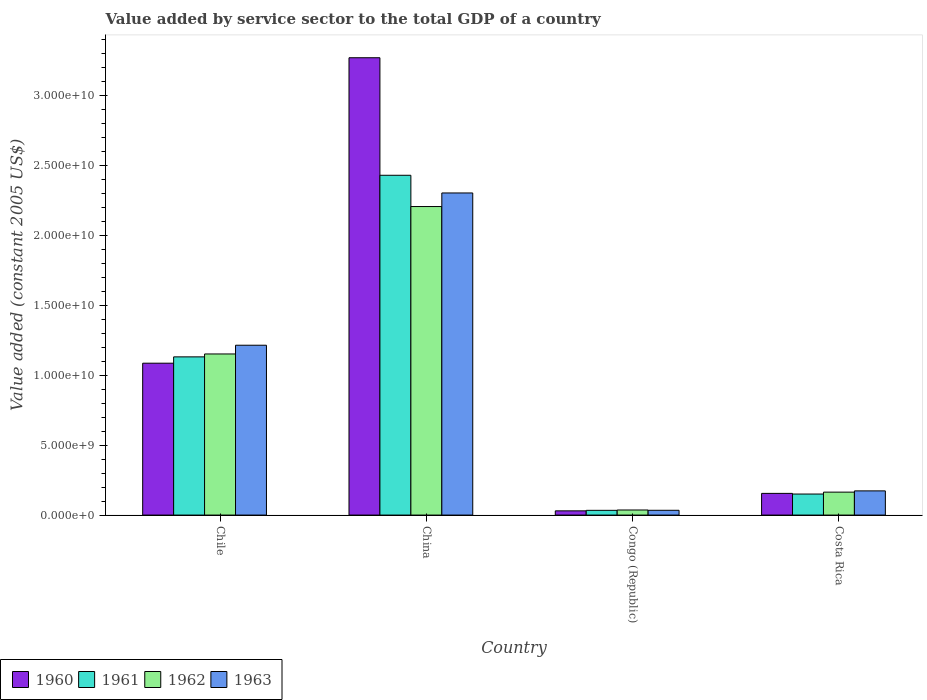How many bars are there on the 3rd tick from the left?
Provide a short and direct response. 4. How many bars are there on the 1st tick from the right?
Offer a very short reply. 4. What is the value added by service sector in 1963 in Costa Rica?
Provide a succinct answer. 1.73e+09. Across all countries, what is the maximum value added by service sector in 1963?
Provide a succinct answer. 2.30e+1. Across all countries, what is the minimum value added by service sector in 1961?
Your answer should be compact. 3.39e+08. In which country was the value added by service sector in 1961 minimum?
Ensure brevity in your answer.  Congo (Republic). What is the total value added by service sector in 1960 in the graph?
Offer a terse response. 4.54e+1. What is the difference between the value added by service sector in 1963 in China and that in Congo (Republic)?
Make the answer very short. 2.27e+1. What is the difference between the value added by service sector in 1961 in Chile and the value added by service sector in 1963 in Congo (Republic)?
Make the answer very short. 1.10e+1. What is the average value added by service sector in 1963 per country?
Keep it short and to the point. 9.32e+09. What is the difference between the value added by service sector of/in 1962 and value added by service sector of/in 1963 in Chile?
Your answer should be very brief. -6.25e+08. What is the ratio of the value added by service sector in 1960 in Congo (Republic) to that in Costa Rica?
Your answer should be compact. 0.19. Is the difference between the value added by service sector in 1962 in China and Congo (Republic) greater than the difference between the value added by service sector in 1963 in China and Congo (Republic)?
Ensure brevity in your answer.  No. What is the difference between the highest and the second highest value added by service sector in 1963?
Keep it short and to the point. -2.13e+1. What is the difference between the highest and the lowest value added by service sector in 1960?
Offer a very short reply. 3.24e+1. Is it the case that in every country, the sum of the value added by service sector in 1960 and value added by service sector in 1963 is greater than the value added by service sector in 1961?
Your response must be concise. Yes. How many bars are there?
Offer a very short reply. 16. Are the values on the major ticks of Y-axis written in scientific E-notation?
Make the answer very short. Yes. Does the graph contain any zero values?
Give a very brief answer. No. Does the graph contain grids?
Give a very brief answer. No. Where does the legend appear in the graph?
Provide a succinct answer. Bottom left. How many legend labels are there?
Offer a very short reply. 4. How are the legend labels stacked?
Keep it short and to the point. Horizontal. What is the title of the graph?
Your answer should be compact. Value added by service sector to the total GDP of a country. Does "2013" appear as one of the legend labels in the graph?
Offer a terse response. No. What is the label or title of the X-axis?
Keep it short and to the point. Country. What is the label or title of the Y-axis?
Ensure brevity in your answer.  Value added (constant 2005 US$). What is the Value added (constant 2005 US$) of 1960 in Chile?
Your response must be concise. 1.09e+1. What is the Value added (constant 2005 US$) in 1961 in Chile?
Your answer should be compact. 1.13e+1. What is the Value added (constant 2005 US$) of 1962 in Chile?
Provide a short and direct response. 1.15e+1. What is the Value added (constant 2005 US$) of 1963 in Chile?
Keep it short and to the point. 1.22e+1. What is the Value added (constant 2005 US$) of 1960 in China?
Provide a short and direct response. 3.27e+1. What is the Value added (constant 2005 US$) in 1961 in China?
Offer a very short reply. 2.43e+1. What is the Value added (constant 2005 US$) of 1962 in China?
Give a very brief answer. 2.21e+1. What is the Value added (constant 2005 US$) of 1963 in China?
Make the answer very short. 2.30e+1. What is the Value added (constant 2005 US$) in 1960 in Congo (Republic)?
Make the answer very short. 3.02e+08. What is the Value added (constant 2005 US$) in 1961 in Congo (Republic)?
Provide a succinct answer. 3.39e+08. What is the Value added (constant 2005 US$) in 1962 in Congo (Republic)?
Your response must be concise. 3.64e+08. What is the Value added (constant 2005 US$) in 1963 in Congo (Republic)?
Your response must be concise. 3.42e+08. What is the Value added (constant 2005 US$) in 1960 in Costa Rica?
Your answer should be very brief. 1.55e+09. What is the Value added (constant 2005 US$) of 1961 in Costa Rica?
Offer a very short reply. 1.51e+09. What is the Value added (constant 2005 US$) of 1962 in Costa Rica?
Provide a succinct answer. 1.64e+09. What is the Value added (constant 2005 US$) in 1963 in Costa Rica?
Keep it short and to the point. 1.73e+09. Across all countries, what is the maximum Value added (constant 2005 US$) of 1960?
Provide a succinct answer. 3.27e+1. Across all countries, what is the maximum Value added (constant 2005 US$) in 1961?
Your answer should be very brief. 2.43e+1. Across all countries, what is the maximum Value added (constant 2005 US$) in 1962?
Your answer should be very brief. 2.21e+1. Across all countries, what is the maximum Value added (constant 2005 US$) of 1963?
Your response must be concise. 2.30e+1. Across all countries, what is the minimum Value added (constant 2005 US$) of 1960?
Provide a succinct answer. 3.02e+08. Across all countries, what is the minimum Value added (constant 2005 US$) of 1961?
Your answer should be very brief. 3.39e+08. Across all countries, what is the minimum Value added (constant 2005 US$) of 1962?
Your response must be concise. 3.64e+08. Across all countries, what is the minimum Value added (constant 2005 US$) in 1963?
Provide a succinct answer. 3.42e+08. What is the total Value added (constant 2005 US$) of 1960 in the graph?
Keep it short and to the point. 4.54e+1. What is the total Value added (constant 2005 US$) in 1961 in the graph?
Your answer should be very brief. 3.75e+1. What is the total Value added (constant 2005 US$) in 1962 in the graph?
Provide a succinct answer. 3.56e+1. What is the total Value added (constant 2005 US$) in 1963 in the graph?
Your answer should be very brief. 3.73e+1. What is the difference between the Value added (constant 2005 US$) of 1960 in Chile and that in China?
Ensure brevity in your answer.  -2.19e+1. What is the difference between the Value added (constant 2005 US$) of 1961 in Chile and that in China?
Provide a short and direct response. -1.30e+1. What is the difference between the Value added (constant 2005 US$) of 1962 in Chile and that in China?
Provide a short and direct response. -1.05e+1. What is the difference between the Value added (constant 2005 US$) of 1963 in Chile and that in China?
Your response must be concise. -1.09e+1. What is the difference between the Value added (constant 2005 US$) in 1960 in Chile and that in Congo (Republic)?
Provide a succinct answer. 1.06e+1. What is the difference between the Value added (constant 2005 US$) of 1961 in Chile and that in Congo (Republic)?
Your answer should be compact. 1.10e+1. What is the difference between the Value added (constant 2005 US$) in 1962 in Chile and that in Congo (Republic)?
Provide a short and direct response. 1.12e+1. What is the difference between the Value added (constant 2005 US$) in 1963 in Chile and that in Congo (Republic)?
Offer a very short reply. 1.18e+1. What is the difference between the Value added (constant 2005 US$) of 1960 in Chile and that in Costa Rica?
Your response must be concise. 9.31e+09. What is the difference between the Value added (constant 2005 US$) of 1961 in Chile and that in Costa Rica?
Your response must be concise. 9.81e+09. What is the difference between the Value added (constant 2005 US$) of 1962 in Chile and that in Costa Rica?
Your response must be concise. 9.89e+09. What is the difference between the Value added (constant 2005 US$) of 1963 in Chile and that in Costa Rica?
Ensure brevity in your answer.  1.04e+1. What is the difference between the Value added (constant 2005 US$) of 1960 in China and that in Congo (Republic)?
Provide a short and direct response. 3.24e+1. What is the difference between the Value added (constant 2005 US$) in 1961 in China and that in Congo (Republic)?
Make the answer very short. 2.40e+1. What is the difference between the Value added (constant 2005 US$) in 1962 in China and that in Congo (Republic)?
Keep it short and to the point. 2.17e+1. What is the difference between the Value added (constant 2005 US$) of 1963 in China and that in Congo (Republic)?
Your answer should be very brief. 2.27e+1. What is the difference between the Value added (constant 2005 US$) in 1960 in China and that in Costa Rica?
Make the answer very short. 3.12e+1. What is the difference between the Value added (constant 2005 US$) in 1961 in China and that in Costa Rica?
Your answer should be very brief. 2.28e+1. What is the difference between the Value added (constant 2005 US$) of 1962 in China and that in Costa Rica?
Offer a very short reply. 2.04e+1. What is the difference between the Value added (constant 2005 US$) in 1963 in China and that in Costa Rica?
Offer a terse response. 2.13e+1. What is the difference between the Value added (constant 2005 US$) of 1960 in Congo (Republic) and that in Costa Rica?
Offer a terse response. -1.25e+09. What is the difference between the Value added (constant 2005 US$) in 1961 in Congo (Republic) and that in Costa Rica?
Make the answer very short. -1.17e+09. What is the difference between the Value added (constant 2005 US$) of 1962 in Congo (Republic) and that in Costa Rica?
Provide a succinct answer. -1.28e+09. What is the difference between the Value added (constant 2005 US$) in 1963 in Congo (Republic) and that in Costa Rica?
Offer a terse response. -1.39e+09. What is the difference between the Value added (constant 2005 US$) in 1960 in Chile and the Value added (constant 2005 US$) in 1961 in China?
Your response must be concise. -1.34e+1. What is the difference between the Value added (constant 2005 US$) of 1960 in Chile and the Value added (constant 2005 US$) of 1962 in China?
Keep it short and to the point. -1.12e+1. What is the difference between the Value added (constant 2005 US$) of 1960 in Chile and the Value added (constant 2005 US$) of 1963 in China?
Provide a succinct answer. -1.22e+1. What is the difference between the Value added (constant 2005 US$) in 1961 in Chile and the Value added (constant 2005 US$) in 1962 in China?
Offer a very short reply. -1.08e+1. What is the difference between the Value added (constant 2005 US$) of 1961 in Chile and the Value added (constant 2005 US$) of 1963 in China?
Your response must be concise. -1.17e+1. What is the difference between the Value added (constant 2005 US$) in 1962 in Chile and the Value added (constant 2005 US$) in 1963 in China?
Give a very brief answer. -1.15e+1. What is the difference between the Value added (constant 2005 US$) of 1960 in Chile and the Value added (constant 2005 US$) of 1961 in Congo (Republic)?
Provide a succinct answer. 1.05e+1. What is the difference between the Value added (constant 2005 US$) in 1960 in Chile and the Value added (constant 2005 US$) in 1962 in Congo (Republic)?
Keep it short and to the point. 1.05e+1. What is the difference between the Value added (constant 2005 US$) of 1960 in Chile and the Value added (constant 2005 US$) of 1963 in Congo (Republic)?
Offer a terse response. 1.05e+1. What is the difference between the Value added (constant 2005 US$) of 1961 in Chile and the Value added (constant 2005 US$) of 1962 in Congo (Republic)?
Give a very brief answer. 1.10e+1. What is the difference between the Value added (constant 2005 US$) of 1961 in Chile and the Value added (constant 2005 US$) of 1963 in Congo (Republic)?
Offer a terse response. 1.10e+1. What is the difference between the Value added (constant 2005 US$) of 1962 in Chile and the Value added (constant 2005 US$) of 1963 in Congo (Republic)?
Your answer should be very brief. 1.12e+1. What is the difference between the Value added (constant 2005 US$) in 1960 in Chile and the Value added (constant 2005 US$) in 1961 in Costa Rica?
Your response must be concise. 9.36e+09. What is the difference between the Value added (constant 2005 US$) in 1960 in Chile and the Value added (constant 2005 US$) in 1962 in Costa Rica?
Offer a very short reply. 9.23e+09. What is the difference between the Value added (constant 2005 US$) of 1960 in Chile and the Value added (constant 2005 US$) of 1963 in Costa Rica?
Ensure brevity in your answer.  9.14e+09. What is the difference between the Value added (constant 2005 US$) of 1961 in Chile and the Value added (constant 2005 US$) of 1962 in Costa Rica?
Your answer should be compact. 9.68e+09. What is the difference between the Value added (constant 2005 US$) of 1961 in Chile and the Value added (constant 2005 US$) of 1963 in Costa Rica?
Your answer should be compact. 9.59e+09. What is the difference between the Value added (constant 2005 US$) of 1962 in Chile and the Value added (constant 2005 US$) of 1963 in Costa Rica?
Offer a terse response. 9.80e+09. What is the difference between the Value added (constant 2005 US$) in 1960 in China and the Value added (constant 2005 US$) in 1961 in Congo (Republic)?
Give a very brief answer. 3.24e+1. What is the difference between the Value added (constant 2005 US$) in 1960 in China and the Value added (constant 2005 US$) in 1962 in Congo (Republic)?
Offer a terse response. 3.24e+1. What is the difference between the Value added (constant 2005 US$) in 1960 in China and the Value added (constant 2005 US$) in 1963 in Congo (Republic)?
Provide a short and direct response. 3.24e+1. What is the difference between the Value added (constant 2005 US$) of 1961 in China and the Value added (constant 2005 US$) of 1962 in Congo (Republic)?
Your answer should be compact. 2.39e+1. What is the difference between the Value added (constant 2005 US$) in 1961 in China and the Value added (constant 2005 US$) in 1963 in Congo (Republic)?
Make the answer very short. 2.40e+1. What is the difference between the Value added (constant 2005 US$) of 1962 in China and the Value added (constant 2005 US$) of 1963 in Congo (Republic)?
Ensure brevity in your answer.  2.17e+1. What is the difference between the Value added (constant 2005 US$) of 1960 in China and the Value added (constant 2005 US$) of 1961 in Costa Rica?
Your answer should be very brief. 3.12e+1. What is the difference between the Value added (constant 2005 US$) in 1960 in China and the Value added (constant 2005 US$) in 1962 in Costa Rica?
Ensure brevity in your answer.  3.11e+1. What is the difference between the Value added (constant 2005 US$) in 1960 in China and the Value added (constant 2005 US$) in 1963 in Costa Rica?
Provide a succinct answer. 3.10e+1. What is the difference between the Value added (constant 2005 US$) in 1961 in China and the Value added (constant 2005 US$) in 1962 in Costa Rica?
Ensure brevity in your answer.  2.27e+1. What is the difference between the Value added (constant 2005 US$) in 1961 in China and the Value added (constant 2005 US$) in 1963 in Costa Rica?
Offer a very short reply. 2.26e+1. What is the difference between the Value added (constant 2005 US$) in 1962 in China and the Value added (constant 2005 US$) in 1963 in Costa Rica?
Ensure brevity in your answer.  2.03e+1. What is the difference between the Value added (constant 2005 US$) in 1960 in Congo (Republic) and the Value added (constant 2005 US$) in 1961 in Costa Rica?
Your answer should be compact. -1.20e+09. What is the difference between the Value added (constant 2005 US$) of 1960 in Congo (Republic) and the Value added (constant 2005 US$) of 1962 in Costa Rica?
Provide a short and direct response. -1.34e+09. What is the difference between the Value added (constant 2005 US$) in 1960 in Congo (Republic) and the Value added (constant 2005 US$) in 1963 in Costa Rica?
Your response must be concise. -1.43e+09. What is the difference between the Value added (constant 2005 US$) of 1961 in Congo (Republic) and the Value added (constant 2005 US$) of 1962 in Costa Rica?
Keep it short and to the point. -1.30e+09. What is the difference between the Value added (constant 2005 US$) in 1961 in Congo (Republic) and the Value added (constant 2005 US$) in 1963 in Costa Rica?
Your answer should be compact. -1.39e+09. What is the difference between the Value added (constant 2005 US$) of 1962 in Congo (Republic) and the Value added (constant 2005 US$) of 1963 in Costa Rica?
Your answer should be very brief. -1.37e+09. What is the average Value added (constant 2005 US$) in 1960 per country?
Make the answer very short. 1.14e+1. What is the average Value added (constant 2005 US$) in 1961 per country?
Ensure brevity in your answer.  9.37e+09. What is the average Value added (constant 2005 US$) of 1962 per country?
Ensure brevity in your answer.  8.90e+09. What is the average Value added (constant 2005 US$) of 1963 per country?
Provide a short and direct response. 9.32e+09. What is the difference between the Value added (constant 2005 US$) in 1960 and Value added (constant 2005 US$) in 1961 in Chile?
Offer a very short reply. -4.53e+08. What is the difference between the Value added (constant 2005 US$) in 1960 and Value added (constant 2005 US$) in 1962 in Chile?
Make the answer very short. -6.60e+08. What is the difference between the Value added (constant 2005 US$) in 1960 and Value added (constant 2005 US$) in 1963 in Chile?
Give a very brief answer. -1.29e+09. What is the difference between the Value added (constant 2005 US$) in 1961 and Value added (constant 2005 US$) in 1962 in Chile?
Offer a very short reply. -2.07e+08. What is the difference between the Value added (constant 2005 US$) in 1961 and Value added (constant 2005 US$) in 1963 in Chile?
Your answer should be very brief. -8.32e+08. What is the difference between the Value added (constant 2005 US$) of 1962 and Value added (constant 2005 US$) of 1963 in Chile?
Provide a short and direct response. -6.25e+08. What is the difference between the Value added (constant 2005 US$) of 1960 and Value added (constant 2005 US$) of 1961 in China?
Make the answer very short. 8.41e+09. What is the difference between the Value added (constant 2005 US$) of 1960 and Value added (constant 2005 US$) of 1962 in China?
Make the answer very short. 1.06e+1. What is the difference between the Value added (constant 2005 US$) in 1960 and Value added (constant 2005 US$) in 1963 in China?
Offer a very short reply. 9.68e+09. What is the difference between the Value added (constant 2005 US$) of 1961 and Value added (constant 2005 US$) of 1962 in China?
Offer a terse response. 2.24e+09. What is the difference between the Value added (constant 2005 US$) in 1961 and Value added (constant 2005 US$) in 1963 in China?
Offer a terse response. 1.27e+09. What is the difference between the Value added (constant 2005 US$) in 1962 and Value added (constant 2005 US$) in 1963 in China?
Provide a short and direct response. -9.71e+08. What is the difference between the Value added (constant 2005 US$) of 1960 and Value added (constant 2005 US$) of 1961 in Congo (Republic)?
Your answer should be compact. -3.74e+07. What is the difference between the Value added (constant 2005 US$) of 1960 and Value added (constant 2005 US$) of 1962 in Congo (Republic)?
Provide a short and direct response. -6.23e+07. What is the difference between the Value added (constant 2005 US$) in 1960 and Value added (constant 2005 US$) in 1963 in Congo (Republic)?
Offer a terse response. -4.05e+07. What is the difference between the Value added (constant 2005 US$) in 1961 and Value added (constant 2005 US$) in 1962 in Congo (Republic)?
Ensure brevity in your answer.  -2.49e+07. What is the difference between the Value added (constant 2005 US$) of 1961 and Value added (constant 2005 US$) of 1963 in Congo (Republic)?
Offer a very short reply. -3.09e+06. What is the difference between the Value added (constant 2005 US$) of 1962 and Value added (constant 2005 US$) of 1963 in Congo (Republic)?
Ensure brevity in your answer.  2.18e+07. What is the difference between the Value added (constant 2005 US$) of 1960 and Value added (constant 2005 US$) of 1961 in Costa Rica?
Keep it short and to the point. 4.72e+07. What is the difference between the Value added (constant 2005 US$) in 1960 and Value added (constant 2005 US$) in 1962 in Costa Rica?
Provide a succinct answer. -8.87e+07. What is the difference between the Value added (constant 2005 US$) in 1960 and Value added (constant 2005 US$) in 1963 in Costa Rica?
Your answer should be compact. -1.78e+08. What is the difference between the Value added (constant 2005 US$) of 1961 and Value added (constant 2005 US$) of 1962 in Costa Rica?
Your response must be concise. -1.36e+08. What is the difference between the Value added (constant 2005 US$) in 1961 and Value added (constant 2005 US$) in 1963 in Costa Rica?
Your answer should be compact. -2.25e+08. What is the difference between the Value added (constant 2005 US$) of 1962 and Value added (constant 2005 US$) of 1963 in Costa Rica?
Your response must be concise. -8.94e+07. What is the ratio of the Value added (constant 2005 US$) in 1960 in Chile to that in China?
Offer a very short reply. 0.33. What is the ratio of the Value added (constant 2005 US$) of 1961 in Chile to that in China?
Offer a very short reply. 0.47. What is the ratio of the Value added (constant 2005 US$) of 1962 in Chile to that in China?
Your response must be concise. 0.52. What is the ratio of the Value added (constant 2005 US$) of 1963 in Chile to that in China?
Make the answer very short. 0.53. What is the ratio of the Value added (constant 2005 US$) in 1960 in Chile to that in Congo (Republic)?
Offer a very short reply. 36.04. What is the ratio of the Value added (constant 2005 US$) in 1961 in Chile to that in Congo (Republic)?
Provide a short and direct response. 33.4. What is the ratio of the Value added (constant 2005 US$) of 1962 in Chile to that in Congo (Republic)?
Ensure brevity in your answer.  31.68. What is the ratio of the Value added (constant 2005 US$) of 1963 in Chile to that in Congo (Republic)?
Provide a succinct answer. 35.53. What is the ratio of the Value added (constant 2005 US$) of 1960 in Chile to that in Costa Rica?
Keep it short and to the point. 7. What is the ratio of the Value added (constant 2005 US$) of 1961 in Chile to that in Costa Rica?
Make the answer very short. 7.52. What is the ratio of the Value added (constant 2005 US$) of 1962 in Chile to that in Costa Rica?
Provide a short and direct response. 7.02. What is the ratio of the Value added (constant 2005 US$) in 1963 in Chile to that in Costa Rica?
Provide a succinct answer. 7.02. What is the ratio of the Value added (constant 2005 US$) in 1960 in China to that in Congo (Republic)?
Provide a short and direct response. 108.51. What is the ratio of the Value added (constant 2005 US$) of 1961 in China to that in Congo (Republic)?
Offer a terse response. 71.73. What is the ratio of the Value added (constant 2005 US$) of 1962 in China to that in Congo (Republic)?
Provide a succinct answer. 60.67. What is the ratio of the Value added (constant 2005 US$) of 1963 in China to that in Congo (Republic)?
Give a very brief answer. 67.39. What is the ratio of the Value added (constant 2005 US$) in 1960 in China to that in Costa Rica?
Your response must be concise. 21.08. What is the ratio of the Value added (constant 2005 US$) of 1961 in China to that in Costa Rica?
Your answer should be very brief. 16.15. What is the ratio of the Value added (constant 2005 US$) in 1962 in China to that in Costa Rica?
Give a very brief answer. 13.45. What is the ratio of the Value added (constant 2005 US$) of 1963 in China to that in Costa Rica?
Your answer should be compact. 13.32. What is the ratio of the Value added (constant 2005 US$) in 1960 in Congo (Republic) to that in Costa Rica?
Ensure brevity in your answer.  0.19. What is the ratio of the Value added (constant 2005 US$) in 1961 in Congo (Republic) to that in Costa Rica?
Your response must be concise. 0.23. What is the ratio of the Value added (constant 2005 US$) of 1962 in Congo (Republic) to that in Costa Rica?
Provide a short and direct response. 0.22. What is the ratio of the Value added (constant 2005 US$) in 1963 in Congo (Republic) to that in Costa Rica?
Provide a succinct answer. 0.2. What is the difference between the highest and the second highest Value added (constant 2005 US$) of 1960?
Ensure brevity in your answer.  2.19e+1. What is the difference between the highest and the second highest Value added (constant 2005 US$) of 1961?
Ensure brevity in your answer.  1.30e+1. What is the difference between the highest and the second highest Value added (constant 2005 US$) in 1962?
Your answer should be very brief. 1.05e+1. What is the difference between the highest and the second highest Value added (constant 2005 US$) of 1963?
Provide a short and direct response. 1.09e+1. What is the difference between the highest and the lowest Value added (constant 2005 US$) in 1960?
Provide a short and direct response. 3.24e+1. What is the difference between the highest and the lowest Value added (constant 2005 US$) of 1961?
Your answer should be very brief. 2.40e+1. What is the difference between the highest and the lowest Value added (constant 2005 US$) in 1962?
Offer a very short reply. 2.17e+1. What is the difference between the highest and the lowest Value added (constant 2005 US$) of 1963?
Give a very brief answer. 2.27e+1. 